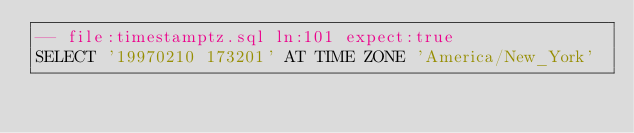Convert code to text. <code><loc_0><loc_0><loc_500><loc_500><_SQL_>-- file:timestamptz.sql ln:101 expect:true
SELECT '19970210 173201' AT TIME ZONE 'America/New_York'
</code> 